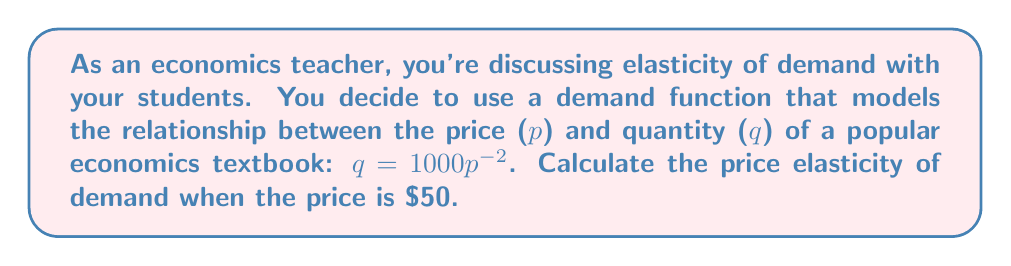Can you answer this question? Let's approach this step-by-step:

1) The formula for price elasticity of demand is:

   $$E_d = \left|\frac{dq}{dp} \cdot \frac{p}{q}\right|$$

2) We need to find $\frac{dq}{dp}$. Our demand function is $q = 1000p^{-2}$. Let's differentiate:

   $$\frac{dq}{dp} = 1000 \cdot (-2)p^{-3} = -2000p^{-3}$$

3) Now, let's substitute this into our elasticity formula:

   $$E_d = \left|-2000p^{-3} \cdot \frac{p}{1000p^{-2}}\right|$$

4) Simplify:

   $$E_d = \left|-2000p^{-3} \cdot \frac{p}{1000p^{-2}}\right| = \left|-2p^{-2}\right| = 2p^{-2}$$

5) Now, we need to calculate this when $p = 50$:

   $$E_d = 2(50)^{-2} = 2 \cdot \frac{1}{2500} = \frac{1}{1250} = 0.0008$$

6) Therefore, the price elasticity of demand when the price is $50 is 0.0008.
Answer: 0.0008 